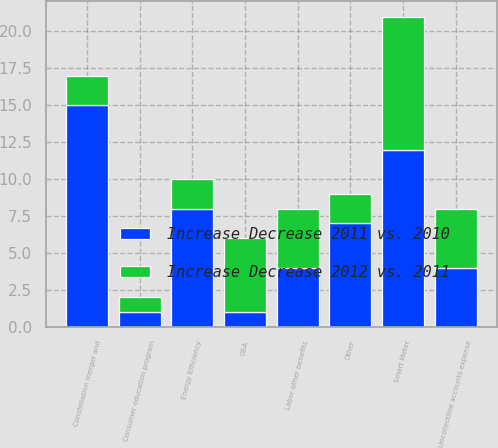Convert chart to OTSL. <chart><loc_0><loc_0><loc_500><loc_500><stacked_bar_chart><ecel><fcel>Labor other benefits<fcel>Uncollectible accounts expense<fcel>Constellation merger and<fcel>Other<fcel>Smart Meter<fcel>Energy Efficiency<fcel>GSA<fcel>Consumer education program<nl><fcel>Increase Decrease 2011 vs. 2010<fcel>4<fcel>4<fcel>15<fcel>7<fcel>12<fcel>8<fcel>1<fcel>1<nl><fcel>Increase Decrease 2012 vs. 2011<fcel>4<fcel>4<fcel>2<fcel>2<fcel>9<fcel>2<fcel>5<fcel>1<nl></chart> 